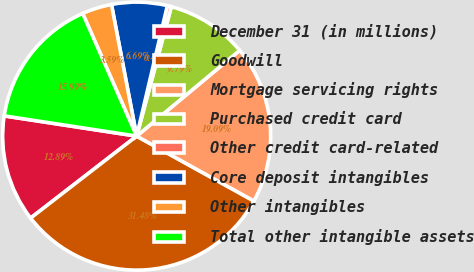<chart> <loc_0><loc_0><loc_500><loc_500><pie_chart><fcel>December 31 (in millions)<fcel>Goodwill<fcel>Mortgage servicing rights<fcel>Purchased credit card<fcel>Other credit card-related<fcel>Core deposit intangibles<fcel>Other intangibles<fcel>Total other intangible assets<nl><fcel>12.89%<fcel>31.49%<fcel>19.09%<fcel>9.79%<fcel>0.49%<fcel>6.69%<fcel>3.59%<fcel>15.99%<nl></chart> 